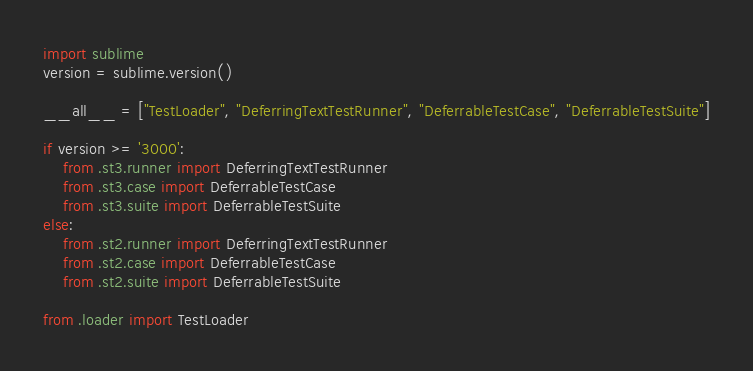Convert code to text. <code><loc_0><loc_0><loc_500><loc_500><_Python_>import sublime
version = sublime.version()

__all__ = ["TestLoader", "DeferringTextTestRunner", "DeferrableTestCase", "DeferrableTestSuite"]

if version >= '3000':
    from .st3.runner import DeferringTextTestRunner
    from .st3.case import DeferrableTestCase
    from .st3.suite import DeferrableTestSuite
else:
    from .st2.runner import DeferringTextTestRunner
    from .st2.case import DeferrableTestCase
    from .st2.suite import DeferrableTestSuite

from .loader import TestLoader
</code> 